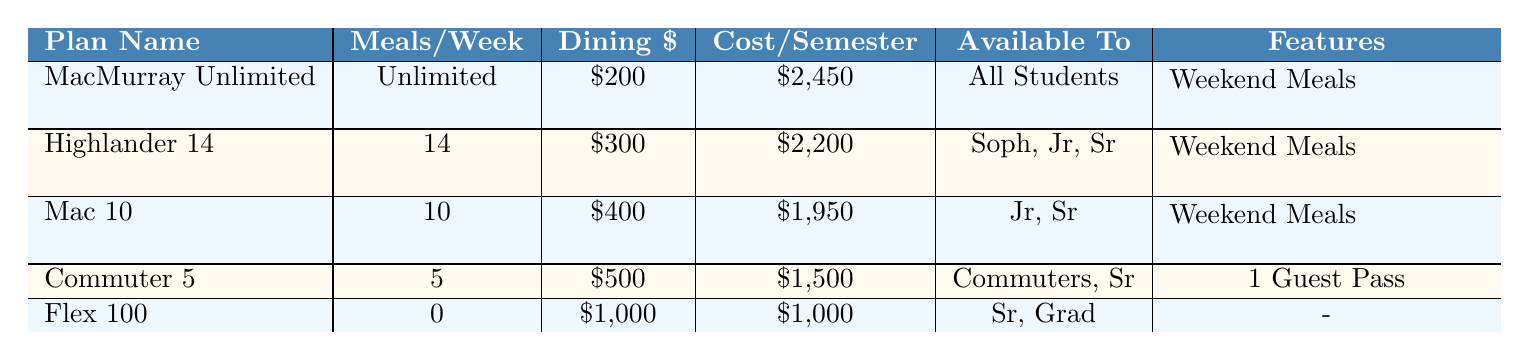What is the cost per semester for the MacMurray Unlimited plan? The table indicates that the cost per semester for the MacMurray Unlimited plan is listed directly as $2,450.
Answer: $2,450 How many guest passes do students get with the Highlander 14 meal plan? The table shows that students with the Highlander 14 plan receive 3 guest passes according to the entry for this meal plan.
Answer: 3 Which meal plan offers the highest number of dining dollars? By reviewing the table, the Flex 100 plan offers the highest dining dollars at $1,000.
Answer: $1,000 What is the total cost of the Commuter 5 and Mac 10 meal plans combined? The Commuter 5 plan costs $1,500 and the Mac 10 plan costs $1,950. Adding these together gives $1,500 + $1,950 = $3,450.
Answer: $3,450 Which meal plan is available only to seniors and graduate students? The table indicates that the Flex 100 meal plan is available specifically to seniors and graduate students.
Answer: Flex 100 Does the Mac 10 plan include weekend meals? According to the table, the Mac 10 meal plan does include weekend meals as specified in its features.
Answer: Yes What is the difference in cost between the most expensive and the cheapest meal plan? The MacMurray Unlimited plan costs $2,450, and the cheapest plan, Flex 100, costs $1,000. The difference in cost is $2,450 - $1,000 = $1,450.
Answer: $1,450 How many meal plans are available to freshmen? By checking the table, only the MacMurray Unlimited meal plan is available to freshmen.
Answer: 1 Which dining location accepts meal swipes and dining dollars? The table shows that both McClelland Dining Hall and MacExpress accept meal swipes and dining dollars.
Answer: McClelland Dining Hall, MacExpress What minimum number of guest passes do students receive with the least expensive meal plan? The least expensive meal plan is Flex 100, which offers 0 guest passes according to the table.
Answer: 0 Based on the available information, which meal plan would you recommend for a student needing unlimited meals? The MacMurray Unlimited plan is the best recommendation for a student needing unlimited meals as it explicitly offers unlimited meals per week.
Answer: MacMurray Unlimited 